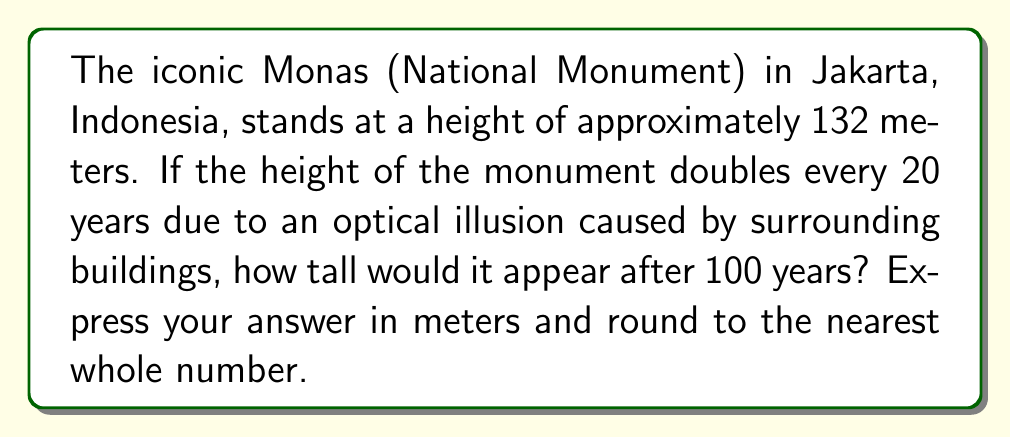Could you help me with this problem? Let's approach this step-by-step:

1) First, we need to identify the base, rate, and time for our exponential equation:
   - Initial height: 132 meters
   - Rate: doubles (multiplies by 2) every 20 years
   - Time: 100 years

2) We can express this as an exponential equation:
   $$ H = 132 \cdot 2^x $$
   Where $H$ is the final height and $x$ is the number of 20-year periods in 100 years.

3) To find $x$, we divide 100 by 20:
   $$ x = \frac{100}{20} = 5 $$

4) Now we can plug this into our equation:
   $$ H = 132 \cdot 2^5 $$

5) Let's calculate $2^5$:
   $$ 2^5 = 2 \cdot 2 \cdot 2 \cdot 2 \cdot 2 = 32 $$

6) Now we can multiply:
   $$ H = 132 \cdot 32 = 4,224 $$

7) Rounding to the nearest whole number:
   $$ H \approx 4,224 \text{ meters} $$

Therefore, after 100 years, the Monas would appear to be 4,224 meters tall.
Answer: 4,224 meters 